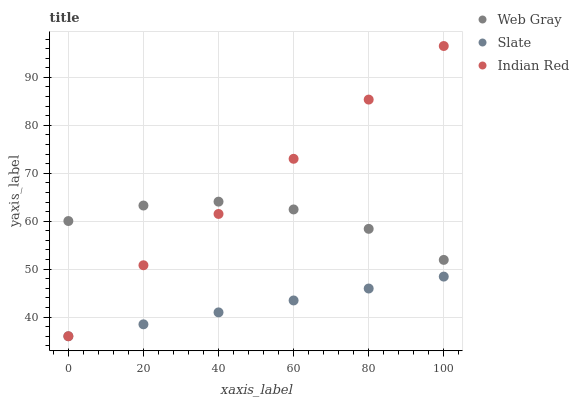Does Slate have the minimum area under the curve?
Answer yes or no. Yes. Does Indian Red have the maximum area under the curve?
Answer yes or no. Yes. Does Web Gray have the minimum area under the curve?
Answer yes or no. No. Does Web Gray have the maximum area under the curve?
Answer yes or no. No. Is Slate the smoothest?
Answer yes or no. Yes. Is Web Gray the roughest?
Answer yes or no. Yes. Is Indian Red the smoothest?
Answer yes or no. No. Is Indian Red the roughest?
Answer yes or no. No. Does Slate have the lowest value?
Answer yes or no. Yes. Does Web Gray have the lowest value?
Answer yes or no. No. Does Indian Red have the highest value?
Answer yes or no. Yes. Does Web Gray have the highest value?
Answer yes or no. No. Is Slate less than Web Gray?
Answer yes or no. Yes. Is Web Gray greater than Slate?
Answer yes or no. Yes. Does Indian Red intersect Slate?
Answer yes or no. Yes. Is Indian Red less than Slate?
Answer yes or no. No. Is Indian Red greater than Slate?
Answer yes or no. No. Does Slate intersect Web Gray?
Answer yes or no. No. 